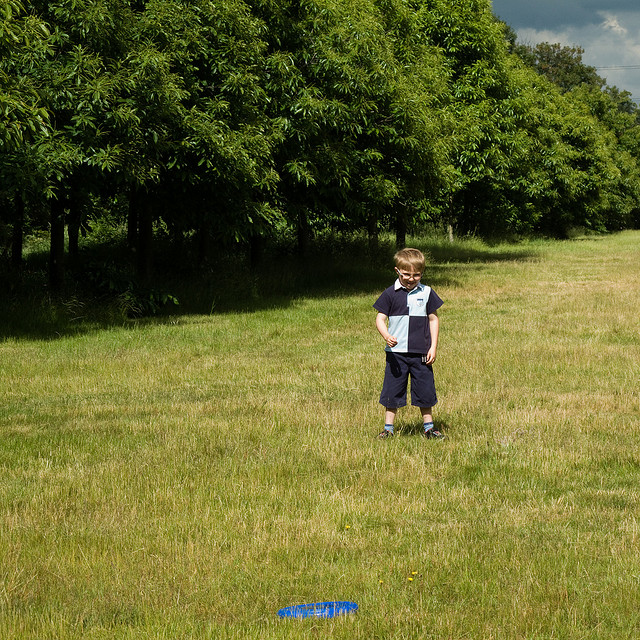<image>Where is sun protection? It is unknown where the sun protection is. However, it can be on the skin or at home. Where is sun protection? I don't know where the sun protection is. However, it can be seen on the skin or on the ground. 